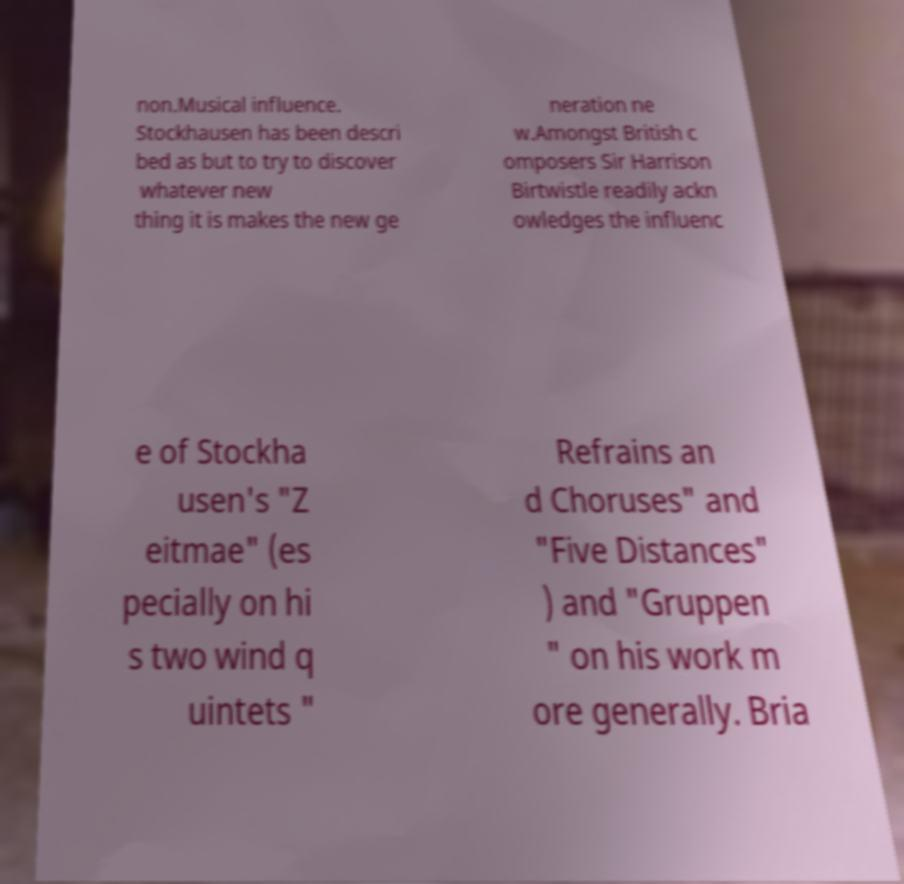For documentation purposes, I need the text within this image transcribed. Could you provide that? non.Musical influence. Stockhausen has been descri bed as but to try to discover whatever new thing it is makes the new ge neration ne w.Amongst British c omposers Sir Harrison Birtwistle readily ackn owledges the influenc e of Stockha usen's "Z eitmae" (es pecially on hi s two wind q uintets " Refrains an d Choruses" and "Five Distances" ) and "Gruppen " on his work m ore generally. Bria 